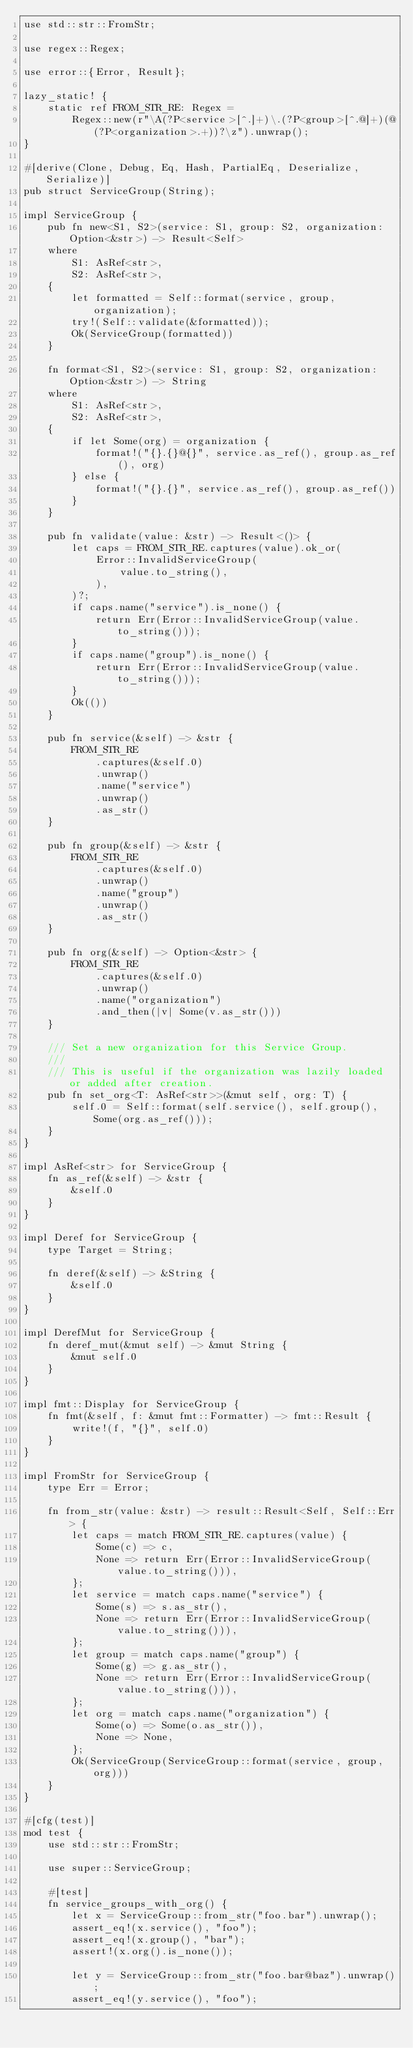<code> <loc_0><loc_0><loc_500><loc_500><_Rust_>use std::str::FromStr;

use regex::Regex;

use error::{Error, Result};

lazy_static! {
    static ref FROM_STR_RE: Regex =
        Regex::new(r"\A(?P<service>[^.]+)\.(?P<group>[^.@]+)(@(?P<organization>.+))?\z").unwrap();
}

#[derive(Clone, Debug, Eq, Hash, PartialEq, Deserialize, Serialize)]
pub struct ServiceGroup(String);

impl ServiceGroup {
    pub fn new<S1, S2>(service: S1, group: S2, organization: Option<&str>) -> Result<Self>
    where
        S1: AsRef<str>,
        S2: AsRef<str>,
    {
        let formatted = Self::format(service, group, organization);
        try!(Self::validate(&formatted));
        Ok(ServiceGroup(formatted))
    }

    fn format<S1, S2>(service: S1, group: S2, organization: Option<&str>) -> String
    where
        S1: AsRef<str>,
        S2: AsRef<str>,
    {
        if let Some(org) = organization {
            format!("{}.{}@{}", service.as_ref(), group.as_ref(), org)
        } else {
            format!("{}.{}", service.as_ref(), group.as_ref())
        }
    }

    pub fn validate(value: &str) -> Result<()> {
        let caps = FROM_STR_RE.captures(value).ok_or(
            Error::InvalidServiceGroup(
                value.to_string(),
            ),
        )?;
        if caps.name("service").is_none() {
            return Err(Error::InvalidServiceGroup(value.to_string()));
        }
        if caps.name("group").is_none() {
            return Err(Error::InvalidServiceGroup(value.to_string()));
        }
        Ok(())
    }

    pub fn service(&self) -> &str {
        FROM_STR_RE
            .captures(&self.0)
            .unwrap()
            .name("service")
            .unwrap()
            .as_str()
    }

    pub fn group(&self) -> &str {
        FROM_STR_RE
            .captures(&self.0)
            .unwrap()
            .name("group")
            .unwrap()
            .as_str()
    }

    pub fn org(&self) -> Option<&str> {
        FROM_STR_RE
            .captures(&self.0)
            .unwrap()
            .name("organization")
            .and_then(|v| Some(v.as_str()))
    }

    /// Set a new organization for this Service Group.
    ///
    /// This is useful if the organization was lazily loaded or added after creation.
    pub fn set_org<T: AsRef<str>>(&mut self, org: T) {
        self.0 = Self::format(self.service(), self.group(), Some(org.as_ref()));
    }
}

impl AsRef<str> for ServiceGroup {
    fn as_ref(&self) -> &str {
        &self.0
    }
}

impl Deref for ServiceGroup {
    type Target = String;

    fn deref(&self) -> &String {
        &self.0
    }
}

impl DerefMut for ServiceGroup {
    fn deref_mut(&mut self) -> &mut String {
        &mut self.0
    }
}

impl fmt::Display for ServiceGroup {
    fn fmt(&self, f: &mut fmt::Formatter) -> fmt::Result {
        write!(f, "{}", self.0)
    }
}

impl FromStr for ServiceGroup {
    type Err = Error;

    fn from_str(value: &str) -> result::Result<Self, Self::Err> {
        let caps = match FROM_STR_RE.captures(value) {
            Some(c) => c,
            None => return Err(Error::InvalidServiceGroup(value.to_string())),
        };
        let service = match caps.name("service") {
            Some(s) => s.as_str(),
            None => return Err(Error::InvalidServiceGroup(value.to_string())),
        };
        let group = match caps.name("group") {
            Some(g) => g.as_str(),
            None => return Err(Error::InvalidServiceGroup(value.to_string())),
        };
        let org = match caps.name("organization") {
            Some(o) => Some(o.as_str()),
            None => None,
        };
        Ok(ServiceGroup(ServiceGroup::format(service, group, org)))
    }
}

#[cfg(test)]
mod test {
    use std::str::FromStr;

    use super::ServiceGroup;

    #[test]
    fn service_groups_with_org() {
        let x = ServiceGroup::from_str("foo.bar").unwrap();
        assert_eq!(x.service(), "foo");
        assert_eq!(x.group(), "bar");
        assert!(x.org().is_none());

        let y = ServiceGroup::from_str("foo.bar@baz").unwrap();
        assert_eq!(y.service(), "foo");</code> 